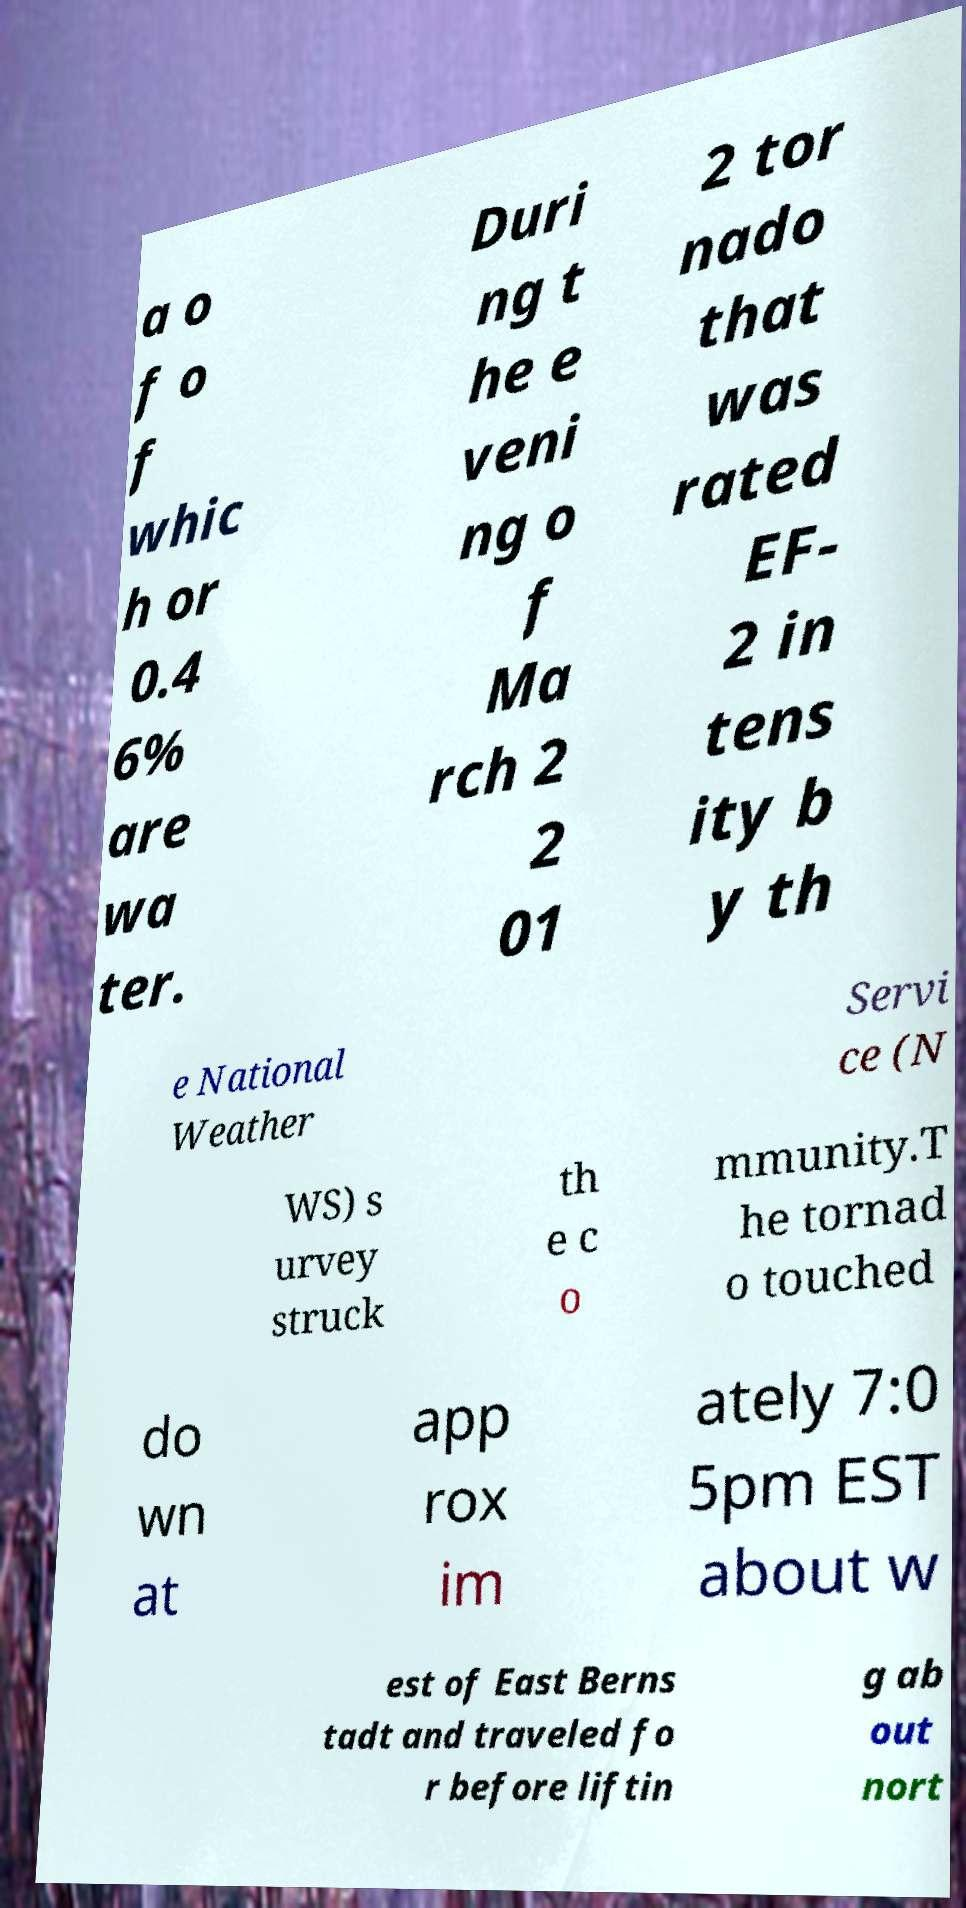What messages or text are displayed in this image? I need them in a readable, typed format. a o f o f whic h or 0.4 6% are wa ter. Duri ng t he e veni ng o f Ma rch 2 2 01 2 tor nado that was rated EF- 2 in tens ity b y th e National Weather Servi ce (N WS) s urvey struck th e c o mmunity.T he tornad o touched do wn at app rox im ately 7:0 5pm EST about w est of East Berns tadt and traveled fo r before liftin g ab out nort 